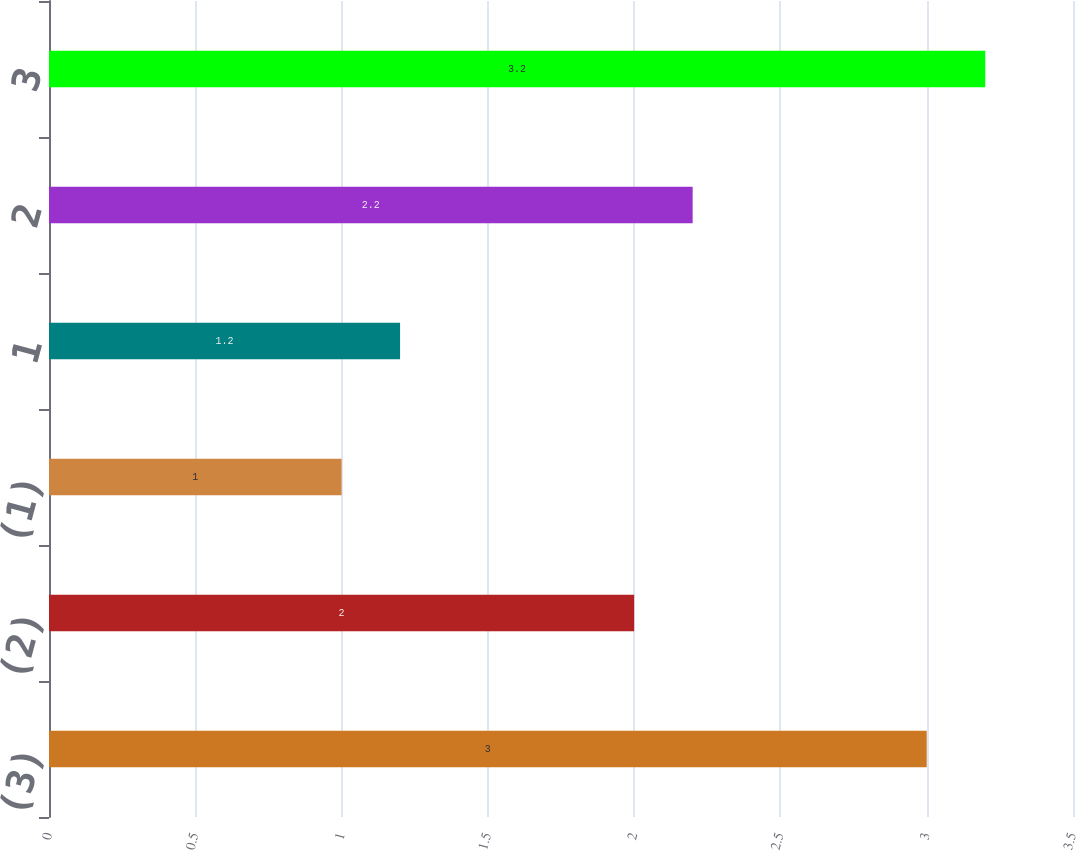Convert chart to OTSL. <chart><loc_0><loc_0><loc_500><loc_500><bar_chart><fcel>(3)<fcel>(2)<fcel>(1)<fcel>1<fcel>2<fcel>3<nl><fcel>3<fcel>2<fcel>1<fcel>1.2<fcel>2.2<fcel>3.2<nl></chart> 